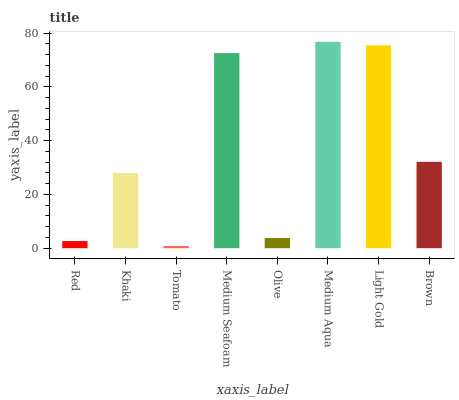Is Tomato the minimum?
Answer yes or no. Yes. Is Medium Aqua the maximum?
Answer yes or no. Yes. Is Khaki the minimum?
Answer yes or no. No. Is Khaki the maximum?
Answer yes or no. No. Is Khaki greater than Red?
Answer yes or no. Yes. Is Red less than Khaki?
Answer yes or no. Yes. Is Red greater than Khaki?
Answer yes or no. No. Is Khaki less than Red?
Answer yes or no. No. Is Brown the high median?
Answer yes or no. Yes. Is Khaki the low median?
Answer yes or no. Yes. Is Olive the high median?
Answer yes or no. No. Is Medium Aqua the low median?
Answer yes or no. No. 